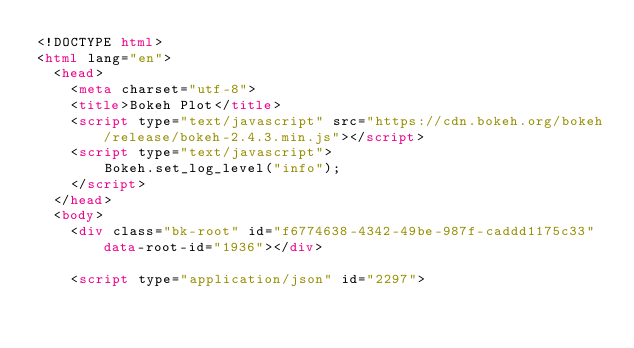Convert code to text. <code><loc_0><loc_0><loc_500><loc_500><_HTML_><!DOCTYPE html>
<html lang="en">
  <head>
    <meta charset="utf-8">
    <title>Bokeh Plot</title>
    <script type="text/javascript" src="https://cdn.bokeh.org/bokeh/release/bokeh-2.4.3.min.js"></script>
    <script type="text/javascript">
        Bokeh.set_log_level("info");
    </script>
  </head>
  <body>
    <div class="bk-root" id="f6774638-4342-49be-987f-caddd1175c33" data-root-id="1936"></div>
  
    <script type="application/json" id="2297"></code> 